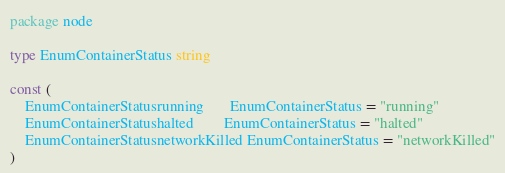<code> <loc_0><loc_0><loc_500><loc_500><_Go_>package node

type EnumContainerStatus string

const (
	EnumContainerStatusrunning       EnumContainerStatus = "running"
	EnumContainerStatushalted        EnumContainerStatus = "halted"
	EnumContainerStatusnetworkKilled EnumContainerStatus = "networkKilled"
)
</code> 